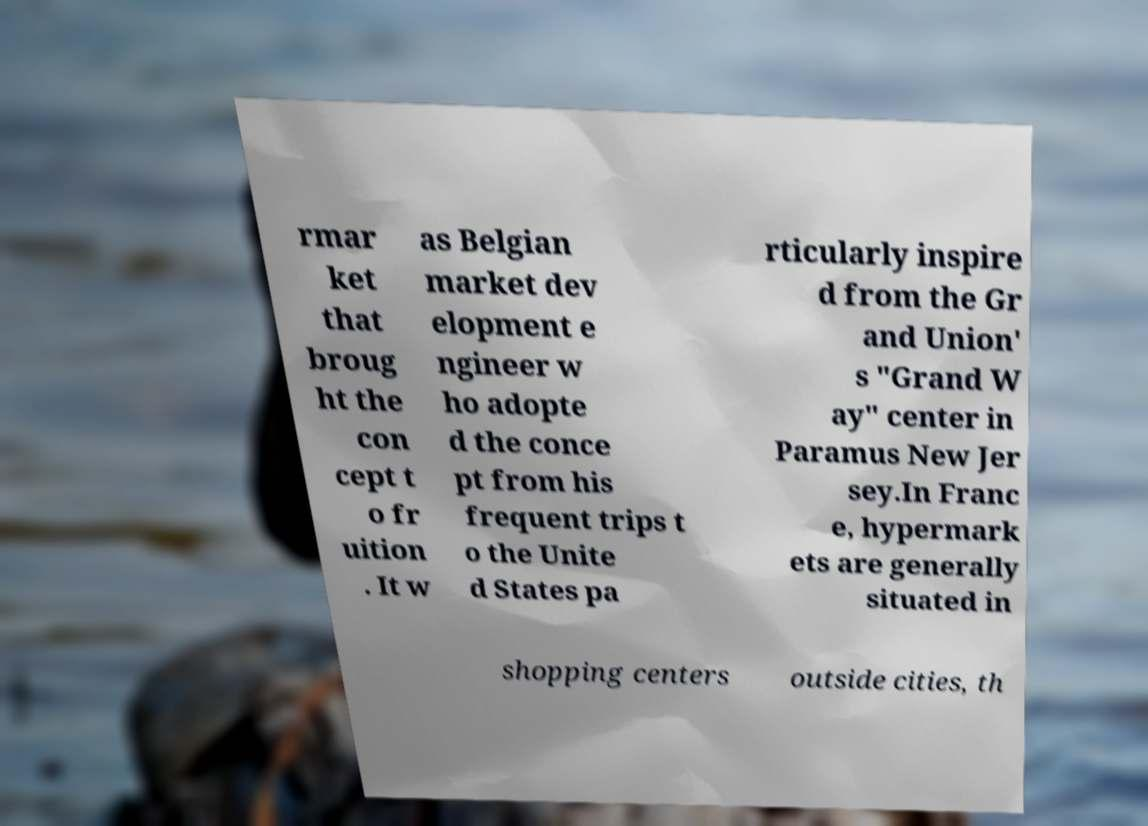Please identify and transcribe the text found in this image. rmar ket that broug ht the con cept t o fr uition . It w as Belgian market dev elopment e ngineer w ho adopte d the conce pt from his frequent trips t o the Unite d States pa rticularly inspire d from the Gr and Union' s "Grand W ay" center in Paramus New Jer sey.In Franc e, hypermark ets are generally situated in shopping centers outside cities, th 